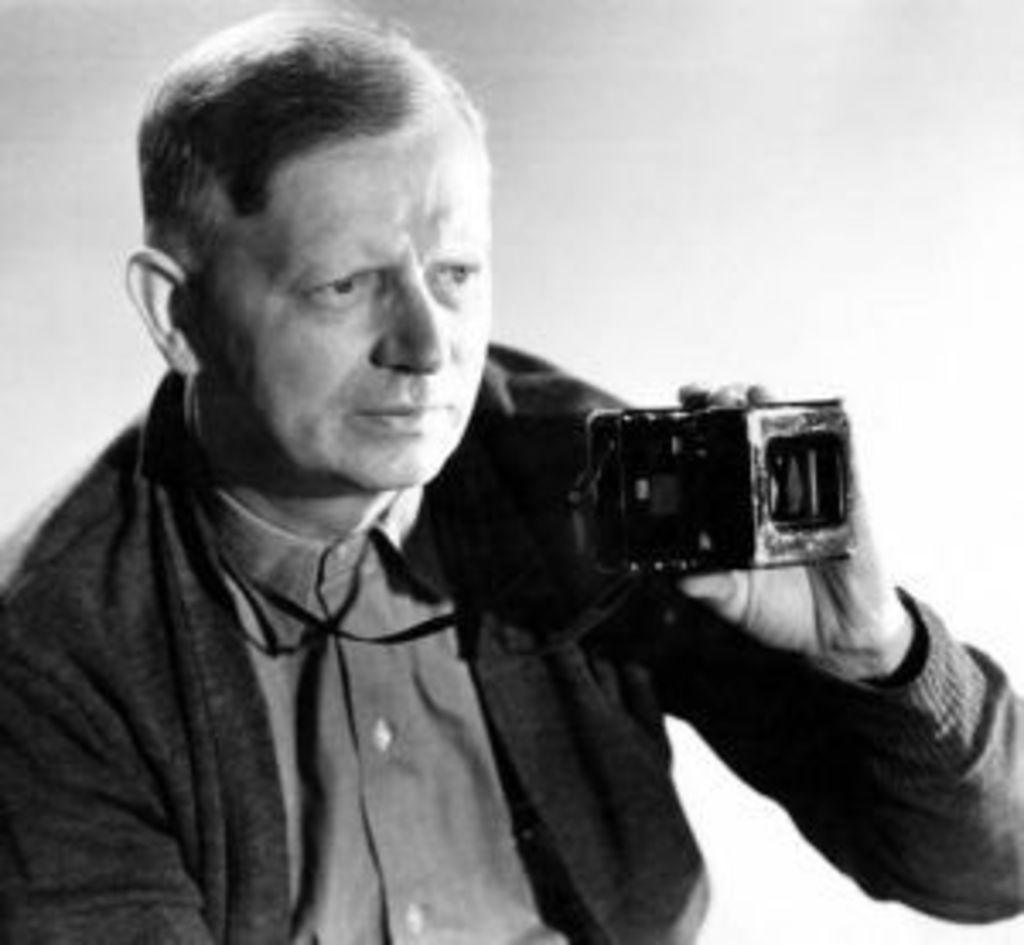Describe this image in one or two sentences. Black and white picture. This person wore black jacket and holds camera. 